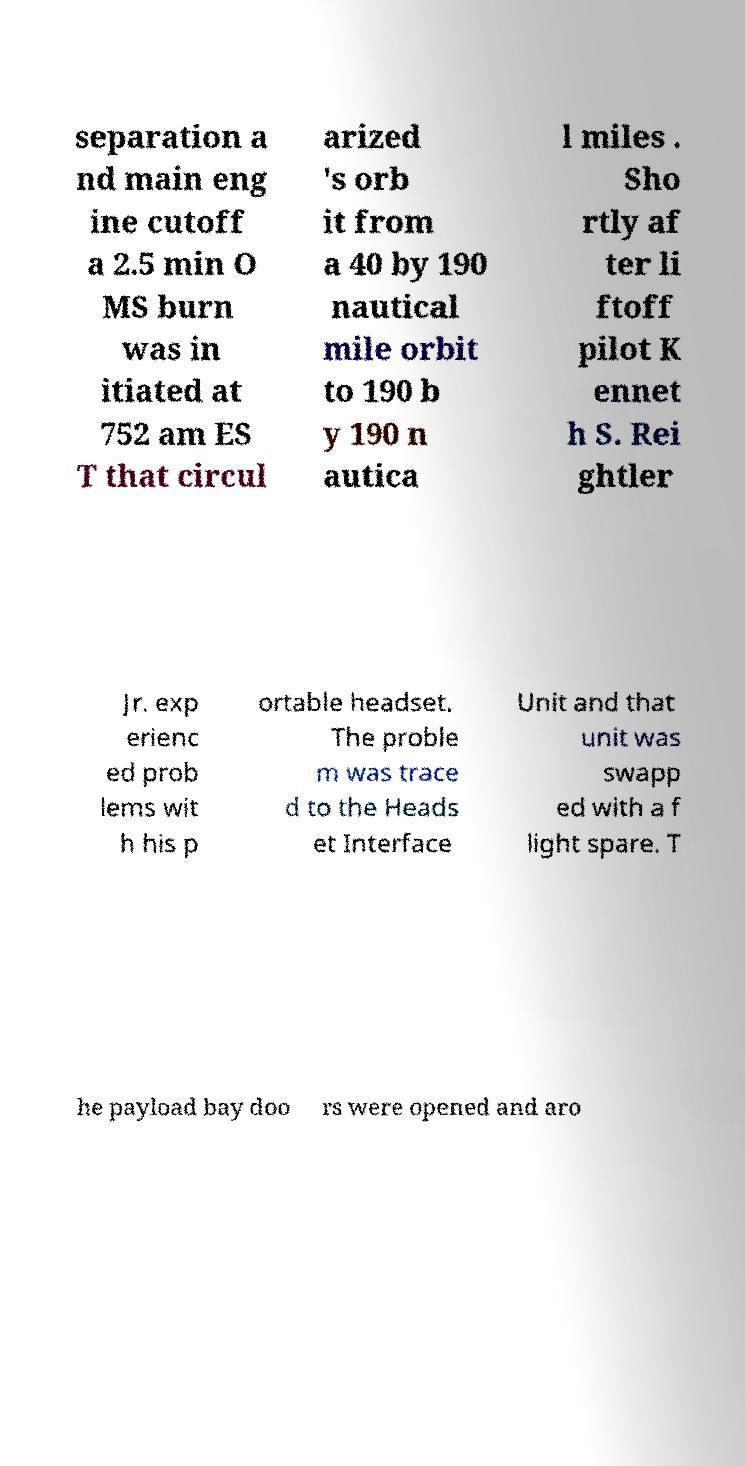Can you accurately transcribe the text from the provided image for me? separation a nd main eng ine cutoff a 2.5 min O MS burn was in itiated at 752 am ES T that circul arized 's orb it from a 40 by 190 nautical mile orbit to 190 b y 190 n autica l miles . Sho rtly af ter li ftoff pilot K ennet h S. Rei ghtler Jr. exp erienc ed prob lems wit h his p ortable headset. The proble m was trace d to the Heads et Interface Unit and that unit was swapp ed with a f light spare. T he payload bay doo rs were opened and aro 